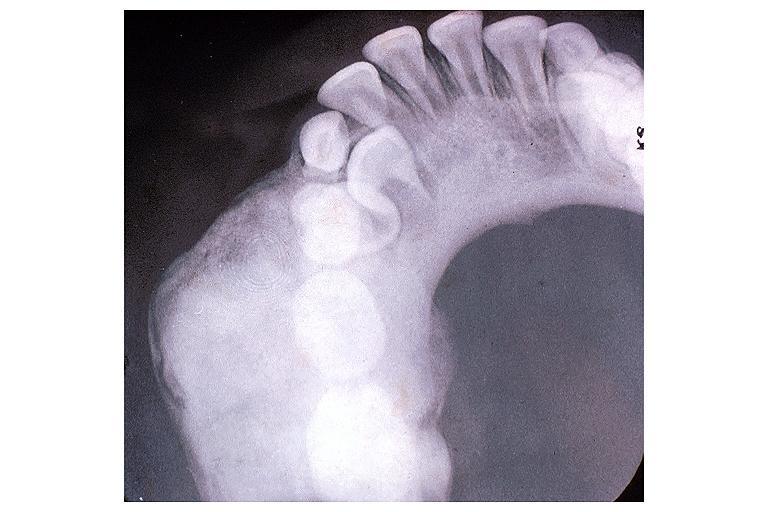does excellent example show osteoblastoma?
Answer the question using a single word or phrase. No 